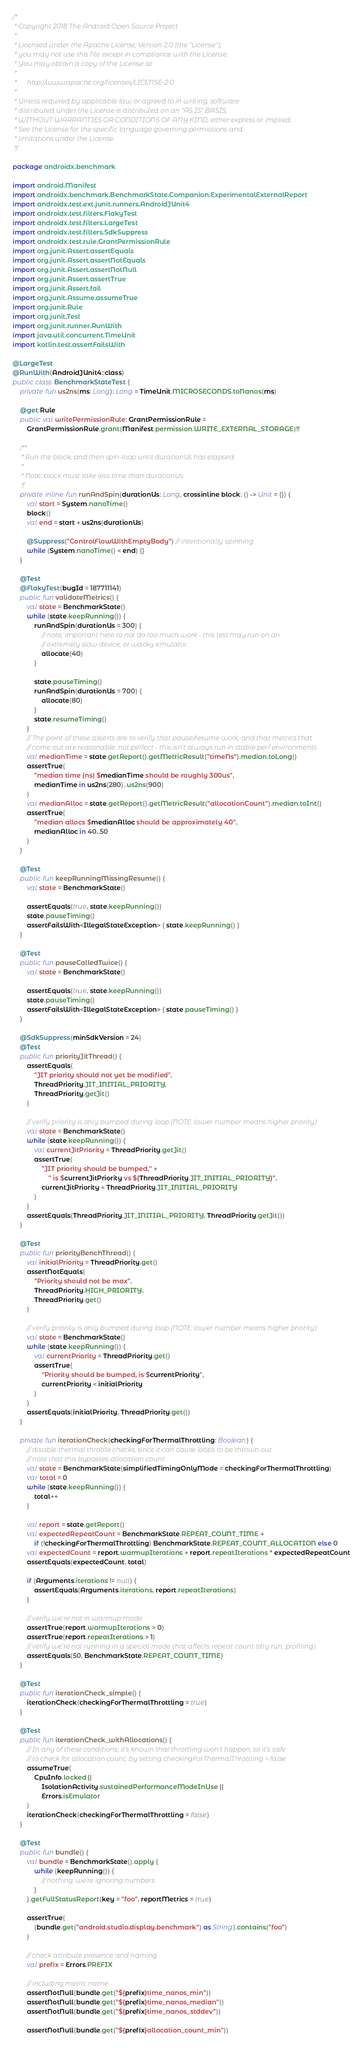<code> <loc_0><loc_0><loc_500><loc_500><_Kotlin_>/*
 * Copyright 2018 The Android Open Source Project
 *
 * Licensed under the Apache License, Version 2.0 (the "License");
 * you may not use this file except in compliance with the License.
 * You may obtain a copy of the License at
 *
 *      http://www.apache.org/licenses/LICENSE-2.0
 *
 * Unless required by applicable law or agreed to in writing, software
 * distributed under the License is distributed on an "AS IS" BASIS,
 * WITHOUT WARRANTIES OR CONDITIONS OF ANY KIND, either express or implied.
 * See the License for the specific language governing permissions and
 * limitations under the License.
 */

package androidx.benchmark

import android.Manifest
import androidx.benchmark.BenchmarkState.Companion.ExperimentalExternalReport
import androidx.test.ext.junit.runners.AndroidJUnit4
import androidx.test.filters.FlakyTest
import androidx.test.filters.LargeTest
import androidx.test.filters.SdkSuppress
import androidx.test.rule.GrantPermissionRule
import org.junit.Assert.assertEquals
import org.junit.Assert.assertNotEquals
import org.junit.Assert.assertNotNull
import org.junit.Assert.assertTrue
import org.junit.Assert.fail
import org.junit.Assume.assumeTrue
import org.junit.Rule
import org.junit.Test
import org.junit.runner.RunWith
import java.util.concurrent.TimeUnit
import kotlin.test.assertFailsWith

@LargeTest
@RunWith(AndroidJUnit4::class)
public class BenchmarkStateTest {
    private fun us2ns(ms: Long): Long = TimeUnit.MICROSECONDS.toNanos(ms)

    @get:Rule
    public val writePermissionRule: GrantPermissionRule =
        GrantPermissionRule.grant(Manifest.permission.WRITE_EXTERNAL_STORAGE)!!

    /**
     * Run the block, and then spin-loop until durationUs has elapsed.
     *
     * Note: block must take less time than durationUs
     */
    private inline fun runAndSpin(durationUs: Long, crossinline block: () -> Unit = {}) {
        val start = System.nanoTime()
        block()
        val end = start + us2ns(durationUs)

        @Suppress("ControlFlowWithEmptyBody") // intentionally spinning
        while (System.nanoTime() < end) {}
    }

    @Test
    @FlakyTest(bugId = 187711141)
    public fun validateMetrics() {
        val state = BenchmarkState()
        while (state.keepRunning()) {
            runAndSpin(durationUs = 300) {
                // note, important here to not do too much work - this test may run on an
                // extremely slow device, or wacky emulator.
                allocate(40)
            }

            state.pauseTiming()
            runAndSpin(durationUs = 700) {
                allocate(80)
            }
            state.resumeTiming()
        }
        // The point of these asserts are to verify that pause/resume work, and that metrics that
        // come out are reasonable, not perfect - this isn't always run in stable perf environments
        val medianTime = state.getReport().getMetricResult("timeNs").median.toLong()
        assertTrue(
            "median time (ns) $medianTime should be roughly 300us",
            medianTime in us2ns(280)..us2ns(900)
        )
        val medianAlloc = state.getReport().getMetricResult("allocationCount").median.toInt()
        assertTrue(
            "median allocs $medianAlloc should be approximately 40",
            medianAlloc in 40..50
        )
    }

    @Test
    public fun keepRunningMissingResume() {
        val state = BenchmarkState()

        assertEquals(true, state.keepRunning())
        state.pauseTiming()
        assertFailsWith<IllegalStateException> { state.keepRunning() }
    }

    @Test
    public fun pauseCalledTwice() {
        val state = BenchmarkState()

        assertEquals(true, state.keepRunning())
        state.pauseTiming()
        assertFailsWith<IllegalStateException> { state.pauseTiming() }
    }

    @SdkSuppress(minSdkVersion = 24)
    @Test
    public fun priorityJitThread() {
        assertEquals(
            "JIT priority should not yet be modified",
            ThreadPriority.JIT_INITIAL_PRIORITY,
            ThreadPriority.getJit()
        )

        // verify priority is only bumped during loop (NOTE: lower number means higher priority)
        val state = BenchmarkState()
        while (state.keepRunning()) {
            val currentJitPriority = ThreadPriority.getJit()
            assertTrue(
                "JIT priority should be bumped," +
                    " is $currentJitPriority vs ${ThreadPriority.JIT_INITIAL_PRIORITY}",
                currentJitPriority < ThreadPriority.JIT_INITIAL_PRIORITY
            )
        }
        assertEquals(ThreadPriority.JIT_INITIAL_PRIORITY, ThreadPriority.getJit())
    }

    @Test
    public fun priorityBenchThread() {
        val initialPriority = ThreadPriority.get()
        assertNotEquals(
            "Priority should not be max",
            ThreadPriority.HIGH_PRIORITY,
            ThreadPriority.get()
        )

        // verify priority is only bumped during loop (NOTE: lower number means higher priority)
        val state = BenchmarkState()
        while (state.keepRunning()) {
            val currentPriority = ThreadPriority.get()
            assertTrue(
                "Priority should be bumped, is $currentPriority",
                currentPriority < initialPriority
            )
        }
        assertEquals(initialPriority, ThreadPriority.get())
    }

    private fun iterationCheck(checkingForThermalThrottling: Boolean) {
        // disable thermal throttle checks, since it can cause loops to be thrown out
        // note that this bypasses allocation count
        val state = BenchmarkState(simplifiedTimingOnlyMode = checkingForThermalThrottling)
        var total = 0
        while (state.keepRunning()) {
            total++
        }

        val report = state.getReport()
        val expectedRepeatCount = BenchmarkState.REPEAT_COUNT_TIME +
            if (!checkingForThermalThrottling) BenchmarkState.REPEAT_COUNT_ALLOCATION else 0
        val expectedCount = report.warmupIterations + report.repeatIterations * expectedRepeatCount
        assertEquals(expectedCount, total)

        if (Arguments.iterations != null) {
            assertEquals(Arguments.iterations, report.repeatIterations)
        }

        // verify we're not in warmup mode
        assertTrue(report.warmupIterations > 0)
        assertTrue(report.repeatIterations > 1)
        // verify we're not running in a special mode that affects repeat count (dry run, profiling)
        assertEquals(50, BenchmarkState.REPEAT_COUNT_TIME)
    }

    @Test
    public fun iterationCheck_simple() {
        iterationCheck(checkingForThermalThrottling = true)
    }

    @Test
    public fun iterationCheck_withAllocations() {
        // In any of these conditions, it's known that throttling won't happen, so it's safe
        // to check for allocation count, by setting checkingForThermalThrottling = false
        assumeTrue(
            CpuInfo.locked ||
                IsolationActivity.sustainedPerformanceModeInUse ||
                Errors.isEmulator
        )
        iterationCheck(checkingForThermalThrottling = false)
    }

    @Test
    public fun bundle() {
        val bundle = BenchmarkState().apply {
            while (keepRunning()) {
                // nothing, we're ignoring numbers
            }
        }.getFullStatusReport(key = "foo", reportMetrics = true)

        assertTrue(
            (bundle.get("android.studio.display.benchmark") as String).contains("foo")
        )

        // check attribute presence and naming
        val prefix = Errors.PREFIX

        // including metric name
        assertNotNull(bundle.get("${prefix}time_nanos_min"))
        assertNotNull(bundle.get("${prefix}time_nanos_median"))
        assertNotNull(bundle.get("${prefix}time_nanos_stddev"))

        assertNotNull(bundle.get("${prefix}allocation_count_min"))</code> 